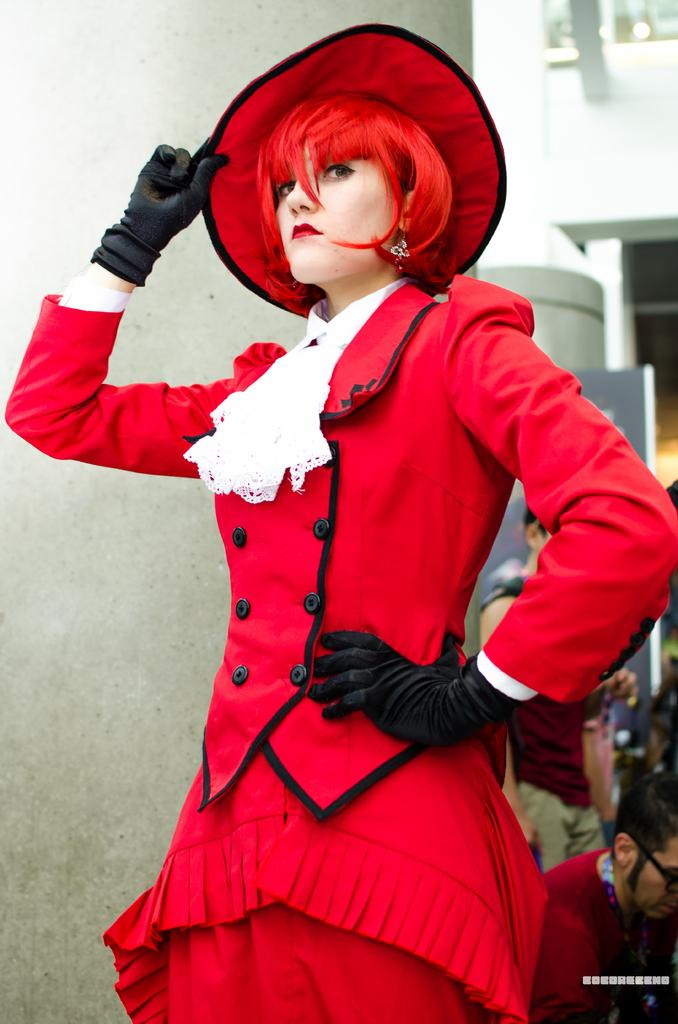What is the woman in the image wearing on her head? The woman is wearing a hat. What else is the woman wearing in the image? The woman is wearing gloves. What can be inferred about the woman's attire from the image? The woman's attire appears to be a costume. What is visible to the left of the woman in the image? There is a wall to the left of the image. What is visible to the right of the woman in the image? There are a few people to the right of the image. What type of sheet is covering the governor in the image? There is no governor or sheet present in the image. 